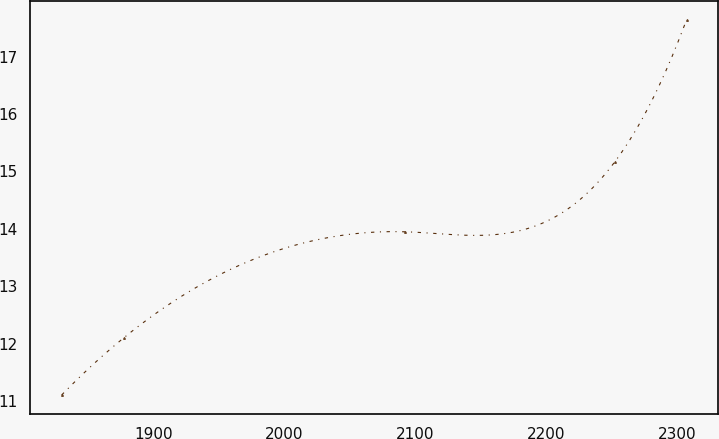Convert chart to OTSL. <chart><loc_0><loc_0><loc_500><loc_500><line_chart><ecel><fcel>Unnamed: 1<nl><fcel>1830.08<fcel>11.11<nl><fcel>1877.79<fcel>12.11<nl><fcel>2092.4<fcel>13.95<nl><fcel>2252.46<fcel>15.17<nl><fcel>2307.14<fcel>17.64<nl></chart> 